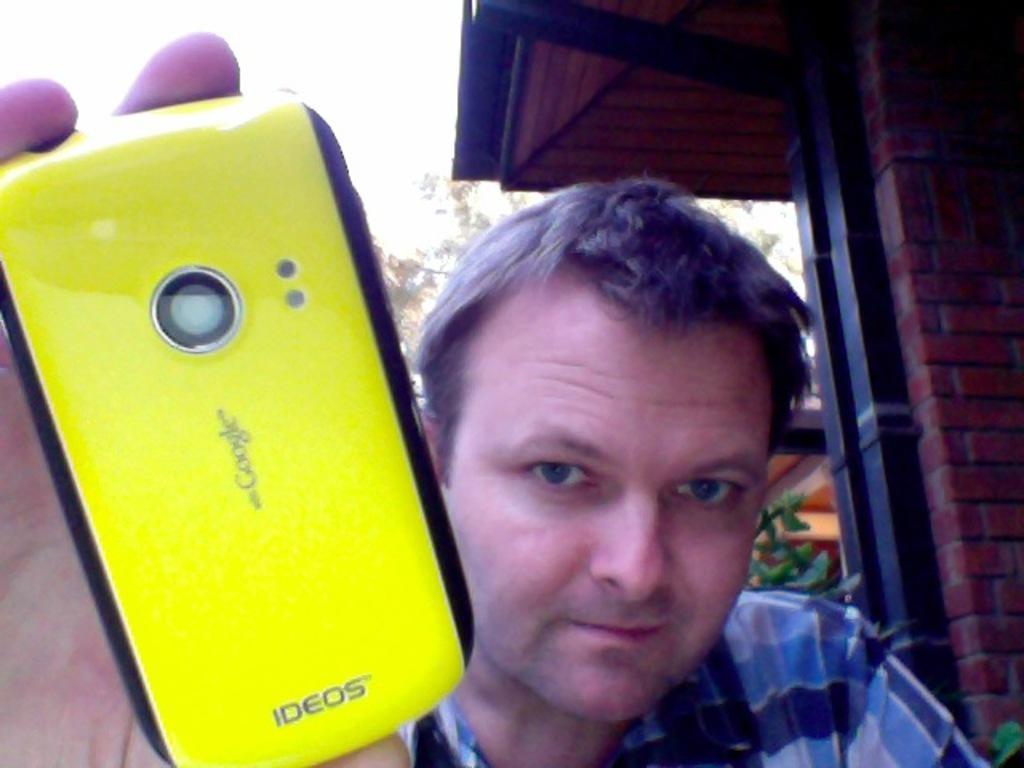Please provide a concise description of this image. In the image we can see there is a man who is standing and holding mobile phone in his hand. 